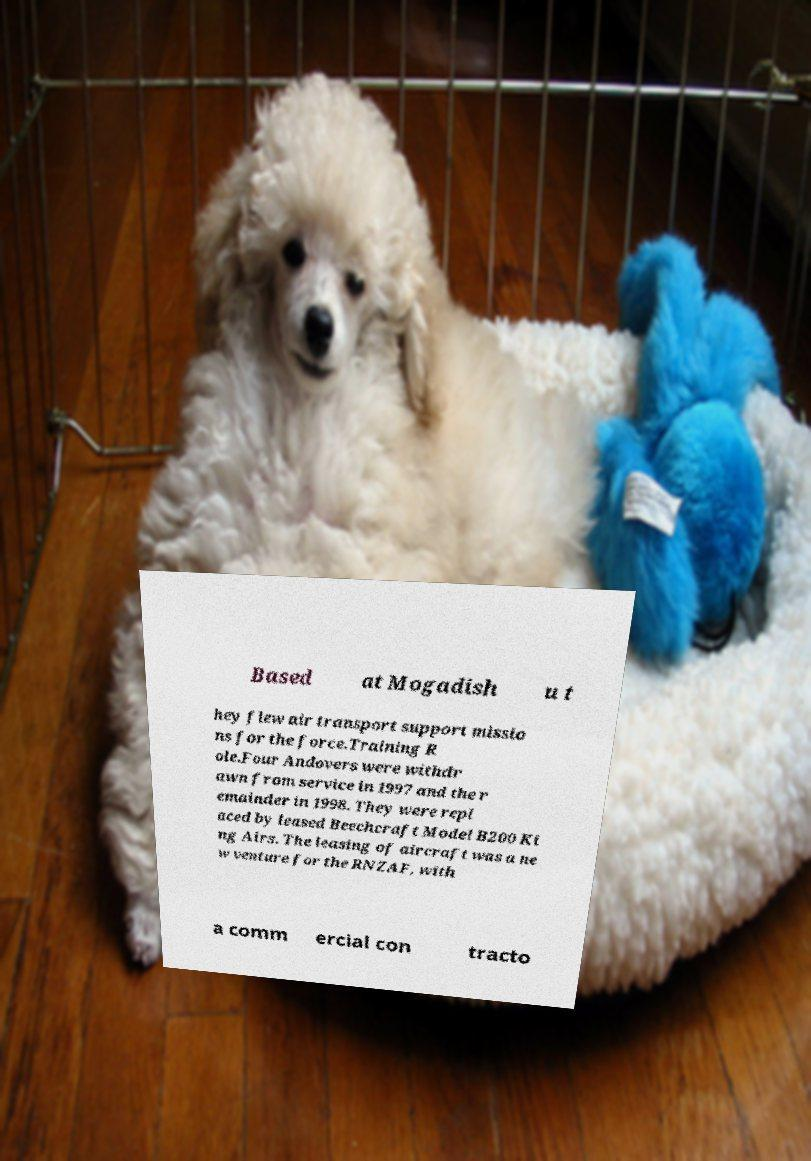Could you assist in decoding the text presented in this image and type it out clearly? Based at Mogadish u t hey flew air transport support missio ns for the force.Training R ole.Four Andovers were withdr awn from service in 1997 and the r emainder in 1998. They were repl aced by leased Beechcraft Model B200 Ki ng Airs. The leasing of aircraft was a ne w venture for the RNZAF, with a comm ercial con tracto 